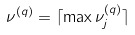Convert formula to latex. <formula><loc_0><loc_0><loc_500><loc_500>\nu ^ { ( q ) } = \lceil \max \nu _ { j } ^ { ( q ) } \rceil</formula> 